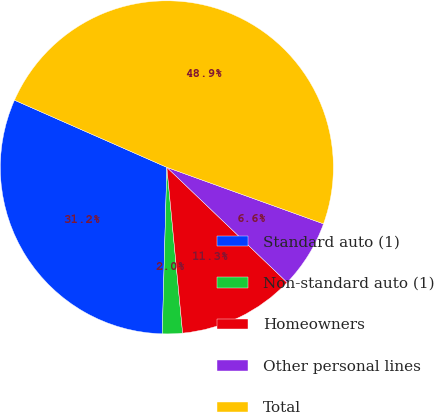<chart> <loc_0><loc_0><loc_500><loc_500><pie_chart><fcel>Standard auto (1)<fcel>Non-standard auto (1)<fcel>Homeowners<fcel>Other personal lines<fcel>Total<nl><fcel>31.17%<fcel>1.95%<fcel>11.34%<fcel>6.64%<fcel>48.9%<nl></chart> 